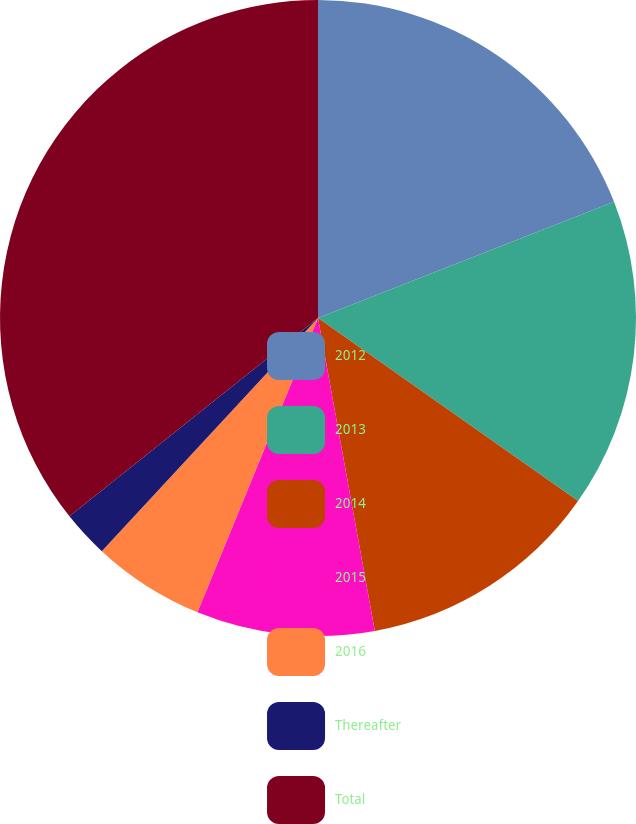<chart> <loc_0><loc_0><loc_500><loc_500><pie_chart><fcel>2012<fcel>2013<fcel>2014<fcel>2015<fcel>2016<fcel>Thereafter<fcel>Total<nl><fcel>19.05%<fcel>15.71%<fcel>12.38%<fcel>9.05%<fcel>5.71%<fcel>2.38%<fcel>35.72%<nl></chart> 